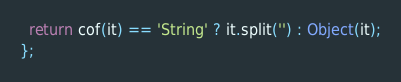<code> <loc_0><loc_0><loc_500><loc_500><_JavaScript_>  return cof(it) == 'String' ? it.split('') : Object(it);
};
</code> 